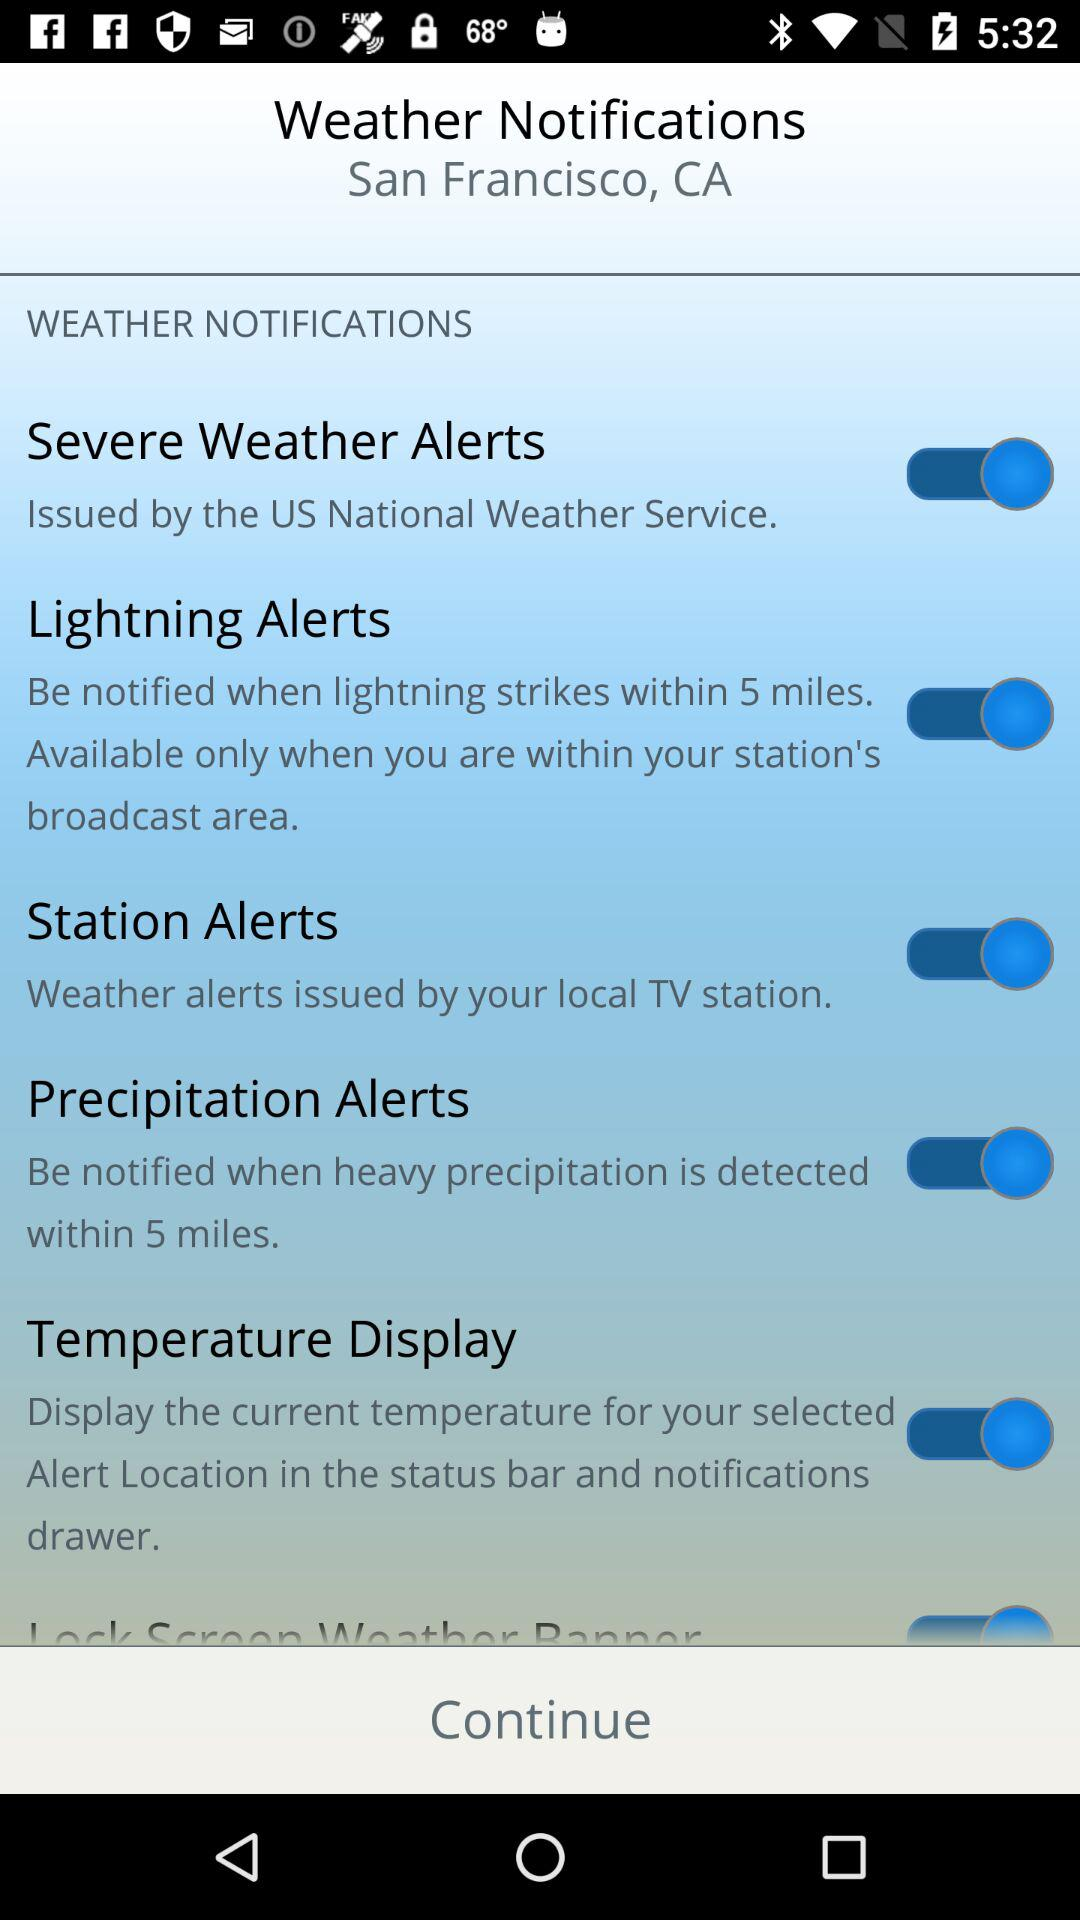Within how many miles will I be notified of the "Precipitation Alerts"? You will be notified within 5 miles. 